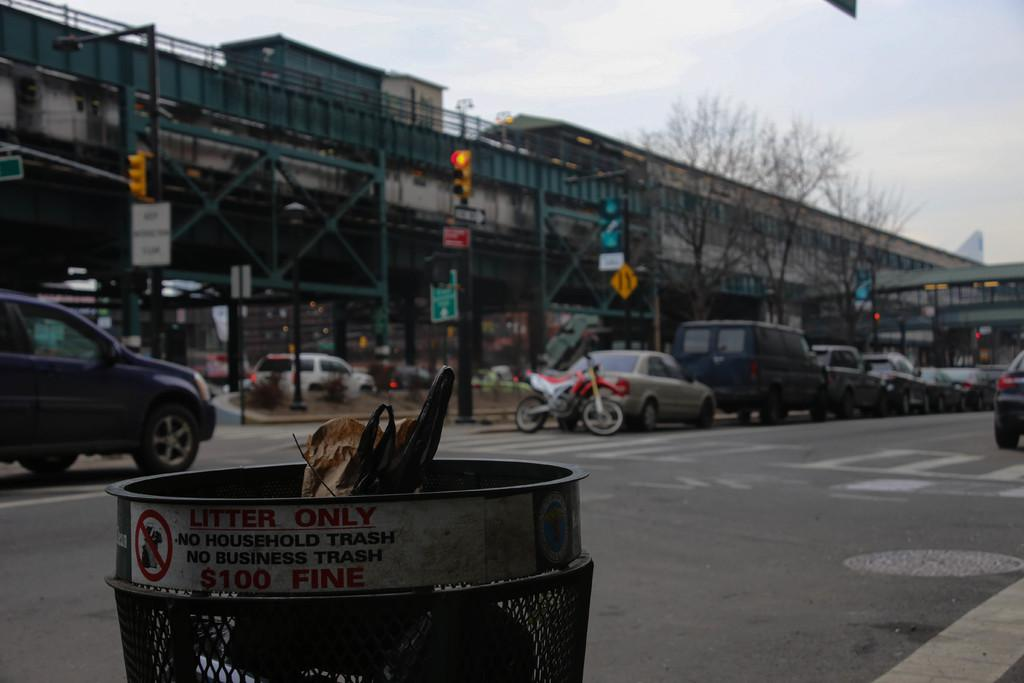What can be seen on the road in the image? There are vehicles on the road in the image. What object is located in front of the vehicles? There is a dustbin in the front of the vehicles. What can be seen in the background of the image? There are buildings in the background of the image. What traffic control device is present in the middle of the road? There is a traffic light in the middle of the road. What is visible above the traffic light? The sky is visible above the traffic light. Can you see a sock hanging from the traffic light in the image? No, there is no sock present in the image. Are there any beetles crawling on the vehicles in the image? No, there are no beetles visible in the image. 